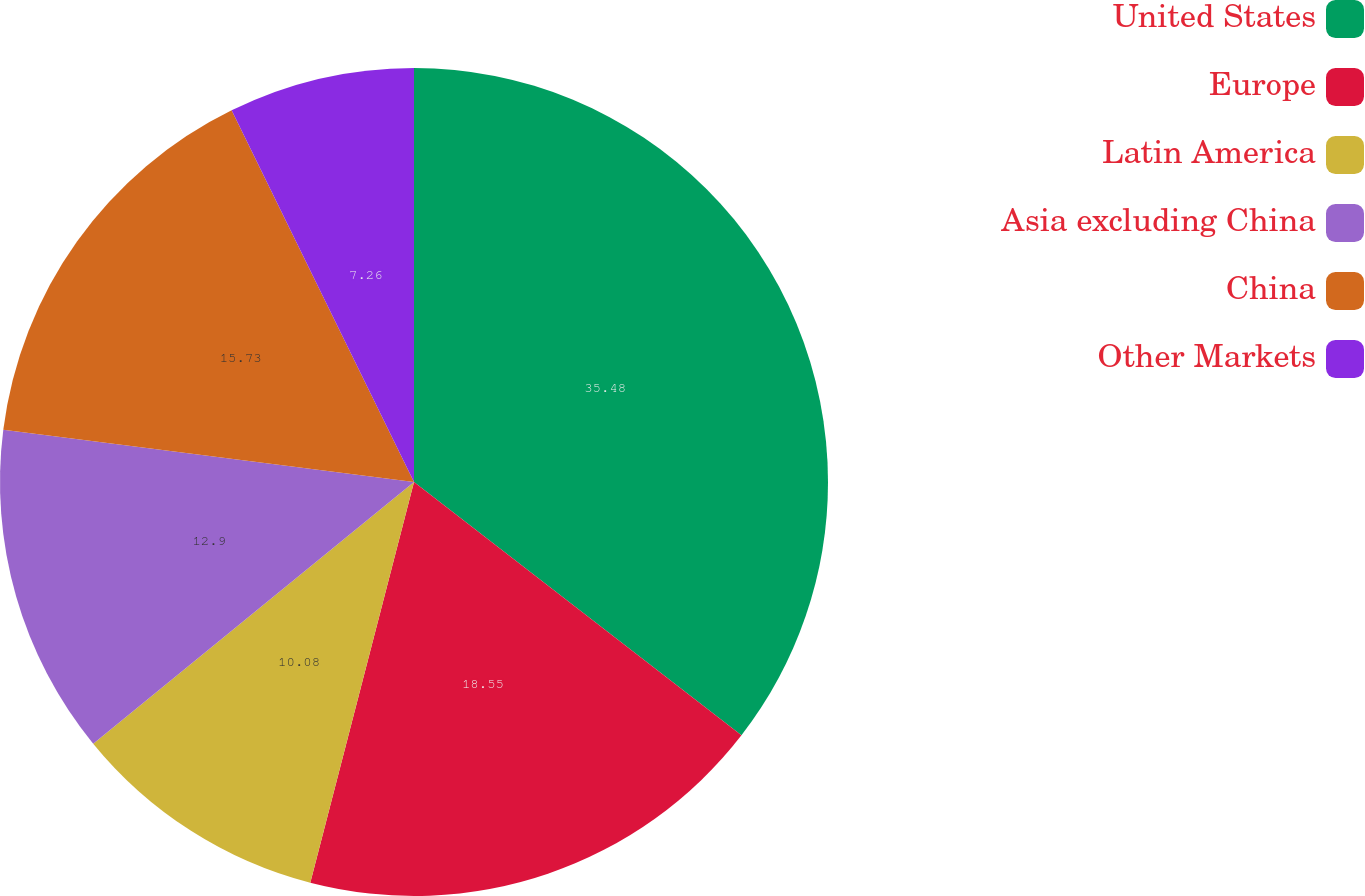<chart> <loc_0><loc_0><loc_500><loc_500><pie_chart><fcel>United States<fcel>Europe<fcel>Latin America<fcel>Asia excluding China<fcel>China<fcel>Other Markets<nl><fcel>35.48%<fcel>18.55%<fcel>10.08%<fcel>12.9%<fcel>15.73%<fcel>7.26%<nl></chart> 